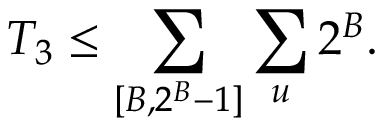<formula> <loc_0><loc_0><loc_500><loc_500>T _ { 3 } \leq \sum _ { [ B , 2 ^ { B } - 1 ] } \sum _ { u } 2 ^ { B } .</formula> 